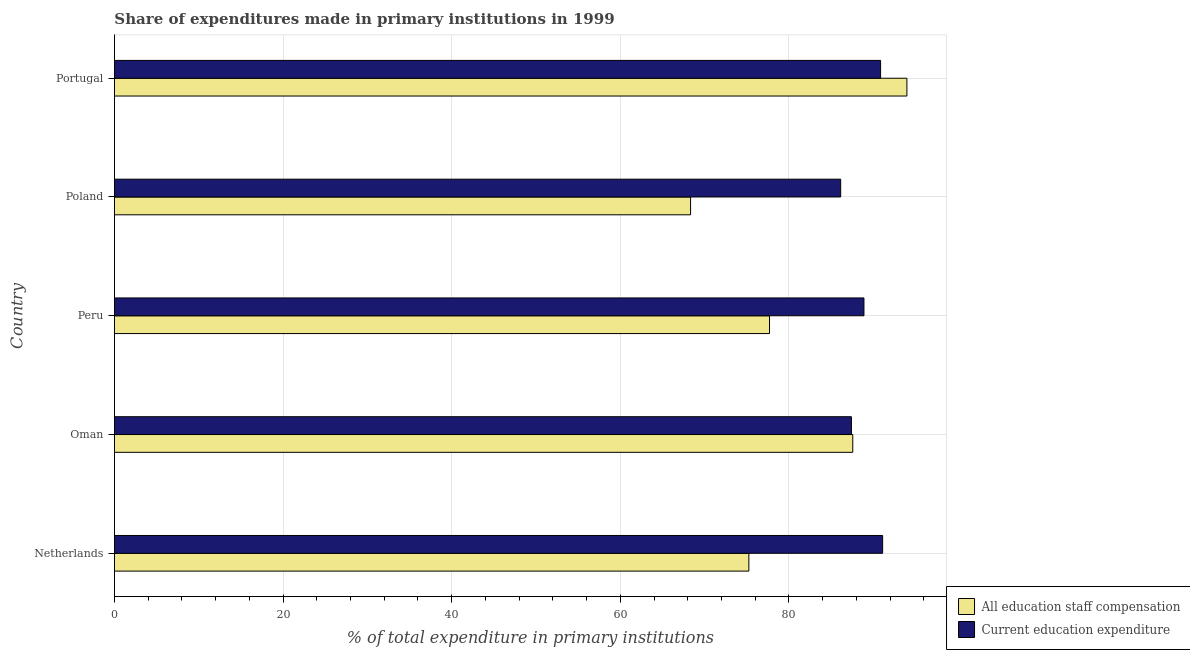How many groups of bars are there?
Provide a succinct answer. 5. Are the number of bars per tick equal to the number of legend labels?
Your answer should be compact. Yes. What is the label of the 3rd group of bars from the top?
Your answer should be very brief. Peru. What is the expenditure in education in Oman?
Provide a succinct answer. 87.41. Across all countries, what is the maximum expenditure in staff compensation?
Provide a succinct answer. 93.99. Across all countries, what is the minimum expenditure in staff compensation?
Ensure brevity in your answer.  68.34. In which country was the expenditure in staff compensation maximum?
Ensure brevity in your answer.  Portugal. In which country was the expenditure in staff compensation minimum?
Your response must be concise. Poland. What is the total expenditure in education in the graph?
Keep it short and to the point. 444.44. What is the difference between the expenditure in staff compensation in Oman and that in Poland?
Make the answer very short. 19.24. What is the difference between the expenditure in education in Netherlands and the expenditure in staff compensation in Oman?
Give a very brief answer. 3.54. What is the average expenditure in staff compensation per country?
Provide a succinct answer. 80.57. What is the difference between the expenditure in staff compensation and expenditure in education in Portugal?
Your answer should be compact. 3.12. Is the expenditure in staff compensation in Oman less than that in Portugal?
Offer a terse response. Yes. What is the difference between the highest and the second highest expenditure in education?
Make the answer very short. 0.24. What is the difference between the highest and the lowest expenditure in staff compensation?
Ensure brevity in your answer.  25.66. What does the 1st bar from the top in Poland represents?
Your answer should be very brief. Current education expenditure. What does the 2nd bar from the bottom in Poland represents?
Your answer should be compact. Current education expenditure. Are all the bars in the graph horizontal?
Your answer should be compact. Yes. How many countries are there in the graph?
Ensure brevity in your answer.  5. What is the difference between two consecutive major ticks on the X-axis?
Provide a short and direct response. 20. Are the values on the major ticks of X-axis written in scientific E-notation?
Ensure brevity in your answer.  No. What is the title of the graph?
Provide a short and direct response. Share of expenditures made in primary institutions in 1999. Does "Goods" appear as one of the legend labels in the graph?
Make the answer very short. No. What is the label or title of the X-axis?
Offer a terse response. % of total expenditure in primary institutions. What is the label or title of the Y-axis?
Provide a short and direct response. Country. What is the % of total expenditure in primary institutions of All education staff compensation in Netherlands?
Make the answer very short. 75.25. What is the % of total expenditure in primary institutions in Current education expenditure in Netherlands?
Ensure brevity in your answer.  91.11. What is the % of total expenditure in primary institutions in All education staff compensation in Oman?
Offer a very short reply. 87.57. What is the % of total expenditure in primary institutions of Current education expenditure in Oman?
Give a very brief answer. 87.41. What is the % of total expenditure in primary institutions of All education staff compensation in Peru?
Keep it short and to the point. 77.7. What is the % of total expenditure in primary institutions of Current education expenditure in Peru?
Offer a terse response. 88.9. What is the % of total expenditure in primary institutions in All education staff compensation in Poland?
Your answer should be very brief. 68.34. What is the % of total expenditure in primary institutions of Current education expenditure in Poland?
Make the answer very short. 86.14. What is the % of total expenditure in primary institutions of All education staff compensation in Portugal?
Give a very brief answer. 93.99. What is the % of total expenditure in primary institutions in Current education expenditure in Portugal?
Give a very brief answer. 90.87. Across all countries, what is the maximum % of total expenditure in primary institutions in All education staff compensation?
Provide a succinct answer. 93.99. Across all countries, what is the maximum % of total expenditure in primary institutions in Current education expenditure?
Keep it short and to the point. 91.11. Across all countries, what is the minimum % of total expenditure in primary institutions in All education staff compensation?
Provide a succinct answer. 68.34. Across all countries, what is the minimum % of total expenditure in primary institutions of Current education expenditure?
Make the answer very short. 86.14. What is the total % of total expenditure in primary institutions of All education staff compensation in the graph?
Your response must be concise. 402.85. What is the total % of total expenditure in primary institutions in Current education expenditure in the graph?
Ensure brevity in your answer.  444.44. What is the difference between the % of total expenditure in primary institutions of All education staff compensation in Netherlands and that in Oman?
Offer a terse response. -12.32. What is the difference between the % of total expenditure in primary institutions in Current education expenditure in Netherlands and that in Oman?
Provide a succinct answer. 3.7. What is the difference between the % of total expenditure in primary institutions of All education staff compensation in Netherlands and that in Peru?
Make the answer very short. -2.45. What is the difference between the % of total expenditure in primary institutions in Current education expenditure in Netherlands and that in Peru?
Offer a very short reply. 2.22. What is the difference between the % of total expenditure in primary institutions in All education staff compensation in Netherlands and that in Poland?
Offer a very short reply. 6.91. What is the difference between the % of total expenditure in primary institutions in Current education expenditure in Netherlands and that in Poland?
Your answer should be very brief. 4.97. What is the difference between the % of total expenditure in primary institutions in All education staff compensation in Netherlands and that in Portugal?
Provide a succinct answer. -18.74. What is the difference between the % of total expenditure in primary institutions in Current education expenditure in Netherlands and that in Portugal?
Your response must be concise. 0.24. What is the difference between the % of total expenditure in primary institutions of All education staff compensation in Oman and that in Peru?
Your answer should be very brief. 9.87. What is the difference between the % of total expenditure in primary institutions in Current education expenditure in Oman and that in Peru?
Provide a short and direct response. -1.48. What is the difference between the % of total expenditure in primary institutions in All education staff compensation in Oman and that in Poland?
Offer a terse response. 19.24. What is the difference between the % of total expenditure in primary institutions of Current education expenditure in Oman and that in Poland?
Your answer should be compact. 1.28. What is the difference between the % of total expenditure in primary institutions in All education staff compensation in Oman and that in Portugal?
Keep it short and to the point. -6.42. What is the difference between the % of total expenditure in primary institutions of Current education expenditure in Oman and that in Portugal?
Offer a terse response. -3.46. What is the difference between the % of total expenditure in primary institutions of All education staff compensation in Peru and that in Poland?
Provide a succinct answer. 9.36. What is the difference between the % of total expenditure in primary institutions in Current education expenditure in Peru and that in Poland?
Your response must be concise. 2.76. What is the difference between the % of total expenditure in primary institutions of All education staff compensation in Peru and that in Portugal?
Make the answer very short. -16.3. What is the difference between the % of total expenditure in primary institutions in Current education expenditure in Peru and that in Portugal?
Ensure brevity in your answer.  -1.97. What is the difference between the % of total expenditure in primary institutions of All education staff compensation in Poland and that in Portugal?
Your answer should be compact. -25.66. What is the difference between the % of total expenditure in primary institutions in Current education expenditure in Poland and that in Portugal?
Offer a very short reply. -4.73. What is the difference between the % of total expenditure in primary institutions in All education staff compensation in Netherlands and the % of total expenditure in primary institutions in Current education expenditure in Oman?
Make the answer very short. -12.17. What is the difference between the % of total expenditure in primary institutions of All education staff compensation in Netherlands and the % of total expenditure in primary institutions of Current education expenditure in Peru?
Provide a succinct answer. -13.65. What is the difference between the % of total expenditure in primary institutions of All education staff compensation in Netherlands and the % of total expenditure in primary institutions of Current education expenditure in Poland?
Your answer should be very brief. -10.89. What is the difference between the % of total expenditure in primary institutions in All education staff compensation in Netherlands and the % of total expenditure in primary institutions in Current education expenditure in Portugal?
Your answer should be very brief. -15.62. What is the difference between the % of total expenditure in primary institutions in All education staff compensation in Oman and the % of total expenditure in primary institutions in Current education expenditure in Peru?
Offer a very short reply. -1.33. What is the difference between the % of total expenditure in primary institutions in All education staff compensation in Oman and the % of total expenditure in primary institutions in Current education expenditure in Poland?
Give a very brief answer. 1.43. What is the difference between the % of total expenditure in primary institutions in All education staff compensation in Oman and the % of total expenditure in primary institutions in Current education expenditure in Portugal?
Your response must be concise. -3.3. What is the difference between the % of total expenditure in primary institutions of All education staff compensation in Peru and the % of total expenditure in primary institutions of Current education expenditure in Poland?
Give a very brief answer. -8.44. What is the difference between the % of total expenditure in primary institutions in All education staff compensation in Peru and the % of total expenditure in primary institutions in Current education expenditure in Portugal?
Provide a short and direct response. -13.17. What is the difference between the % of total expenditure in primary institutions of All education staff compensation in Poland and the % of total expenditure in primary institutions of Current education expenditure in Portugal?
Give a very brief answer. -22.54. What is the average % of total expenditure in primary institutions of All education staff compensation per country?
Ensure brevity in your answer.  80.57. What is the average % of total expenditure in primary institutions of Current education expenditure per country?
Your answer should be very brief. 88.89. What is the difference between the % of total expenditure in primary institutions in All education staff compensation and % of total expenditure in primary institutions in Current education expenditure in Netherlands?
Give a very brief answer. -15.87. What is the difference between the % of total expenditure in primary institutions of All education staff compensation and % of total expenditure in primary institutions of Current education expenditure in Oman?
Your answer should be very brief. 0.16. What is the difference between the % of total expenditure in primary institutions in All education staff compensation and % of total expenditure in primary institutions in Current education expenditure in Peru?
Your answer should be very brief. -11.2. What is the difference between the % of total expenditure in primary institutions of All education staff compensation and % of total expenditure in primary institutions of Current education expenditure in Poland?
Your response must be concise. -17.8. What is the difference between the % of total expenditure in primary institutions of All education staff compensation and % of total expenditure in primary institutions of Current education expenditure in Portugal?
Your response must be concise. 3.12. What is the ratio of the % of total expenditure in primary institutions in All education staff compensation in Netherlands to that in Oman?
Keep it short and to the point. 0.86. What is the ratio of the % of total expenditure in primary institutions in Current education expenditure in Netherlands to that in Oman?
Offer a very short reply. 1.04. What is the ratio of the % of total expenditure in primary institutions in All education staff compensation in Netherlands to that in Peru?
Offer a terse response. 0.97. What is the ratio of the % of total expenditure in primary institutions of Current education expenditure in Netherlands to that in Peru?
Provide a succinct answer. 1.02. What is the ratio of the % of total expenditure in primary institutions of All education staff compensation in Netherlands to that in Poland?
Your response must be concise. 1.1. What is the ratio of the % of total expenditure in primary institutions of Current education expenditure in Netherlands to that in Poland?
Your answer should be very brief. 1.06. What is the ratio of the % of total expenditure in primary institutions in All education staff compensation in Netherlands to that in Portugal?
Your response must be concise. 0.8. What is the ratio of the % of total expenditure in primary institutions in All education staff compensation in Oman to that in Peru?
Make the answer very short. 1.13. What is the ratio of the % of total expenditure in primary institutions in Current education expenditure in Oman to that in Peru?
Provide a short and direct response. 0.98. What is the ratio of the % of total expenditure in primary institutions in All education staff compensation in Oman to that in Poland?
Provide a short and direct response. 1.28. What is the ratio of the % of total expenditure in primary institutions of Current education expenditure in Oman to that in Poland?
Provide a succinct answer. 1.01. What is the ratio of the % of total expenditure in primary institutions of All education staff compensation in Oman to that in Portugal?
Provide a short and direct response. 0.93. What is the ratio of the % of total expenditure in primary institutions of Current education expenditure in Oman to that in Portugal?
Offer a terse response. 0.96. What is the ratio of the % of total expenditure in primary institutions in All education staff compensation in Peru to that in Poland?
Make the answer very short. 1.14. What is the ratio of the % of total expenditure in primary institutions in Current education expenditure in Peru to that in Poland?
Offer a very short reply. 1.03. What is the ratio of the % of total expenditure in primary institutions in All education staff compensation in Peru to that in Portugal?
Your answer should be very brief. 0.83. What is the ratio of the % of total expenditure in primary institutions of Current education expenditure in Peru to that in Portugal?
Offer a terse response. 0.98. What is the ratio of the % of total expenditure in primary institutions of All education staff compensation in Poland to that in Portugal?
Your answer should be compact. 0.73. What is the ratio of the % of total expenditure in primary institutions of Current education expenditure in Poland to that in Portugal?
Ensure brevity in your answer.  0.95. What is the difference between the highest and the second highest % of total expenditure in primary institutions of All education staff compensation?
Offer a terse response. 6.42. What is the difference between the highest and the second highest % of total expenditure in primary institutions in Current education expenditure?
Offer a terse response. 0.24. What is the difference between the highest and the lowest % of total expenditure in primary institutions of All education staff compensation?
Provide a short and direct response. 25.66. What is the difference between the highest and the lowest % of total expenditure in primary institutions of Current education expenditure?
Provide a succinct answer. 4.97. 